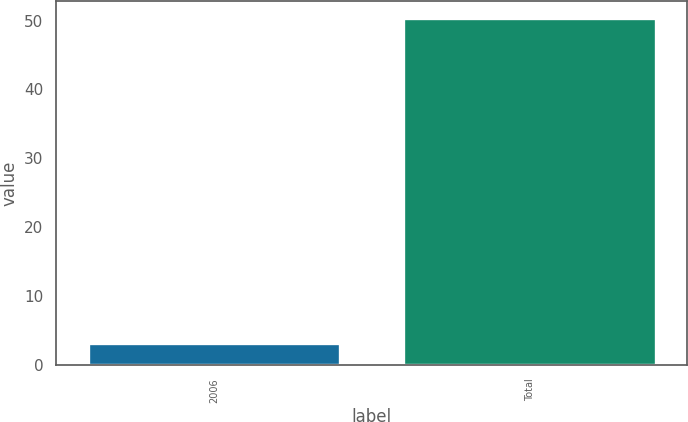<chart> <loc_0><loc_0><loc_500><loc_500><bar_chart><fcel>2006<fcel>Total<nl><fcel>3.1<fcel>50.3<nl></chart> 